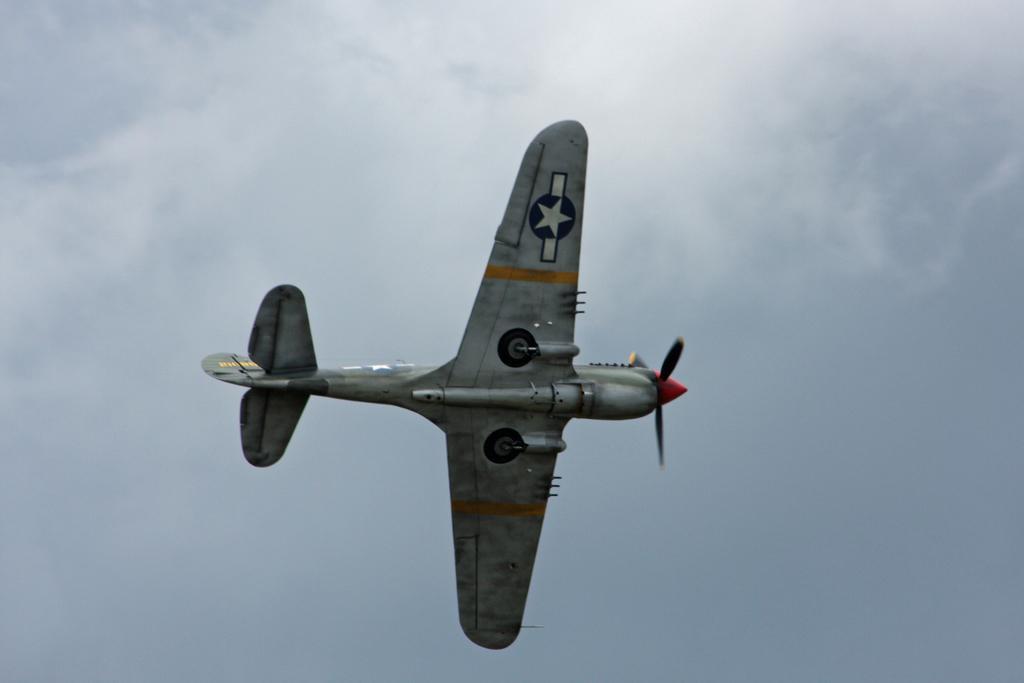In one or two sentences, can you explain what this image depicts? In this picture we can see an aircraft flying in the sky. 